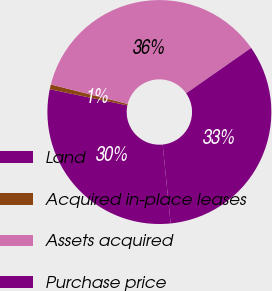<chart> <loc_0><loc_0><loc_500><loc_500><pie_chart><fcel>Land<fcel>Acquired in-place leases<fcel>Assets acquired<fcel>Purchase price<nl><fcel>29.87%<fcel>0.7%<fcel>36.33%<fcel>33.1%<nl></chart> 